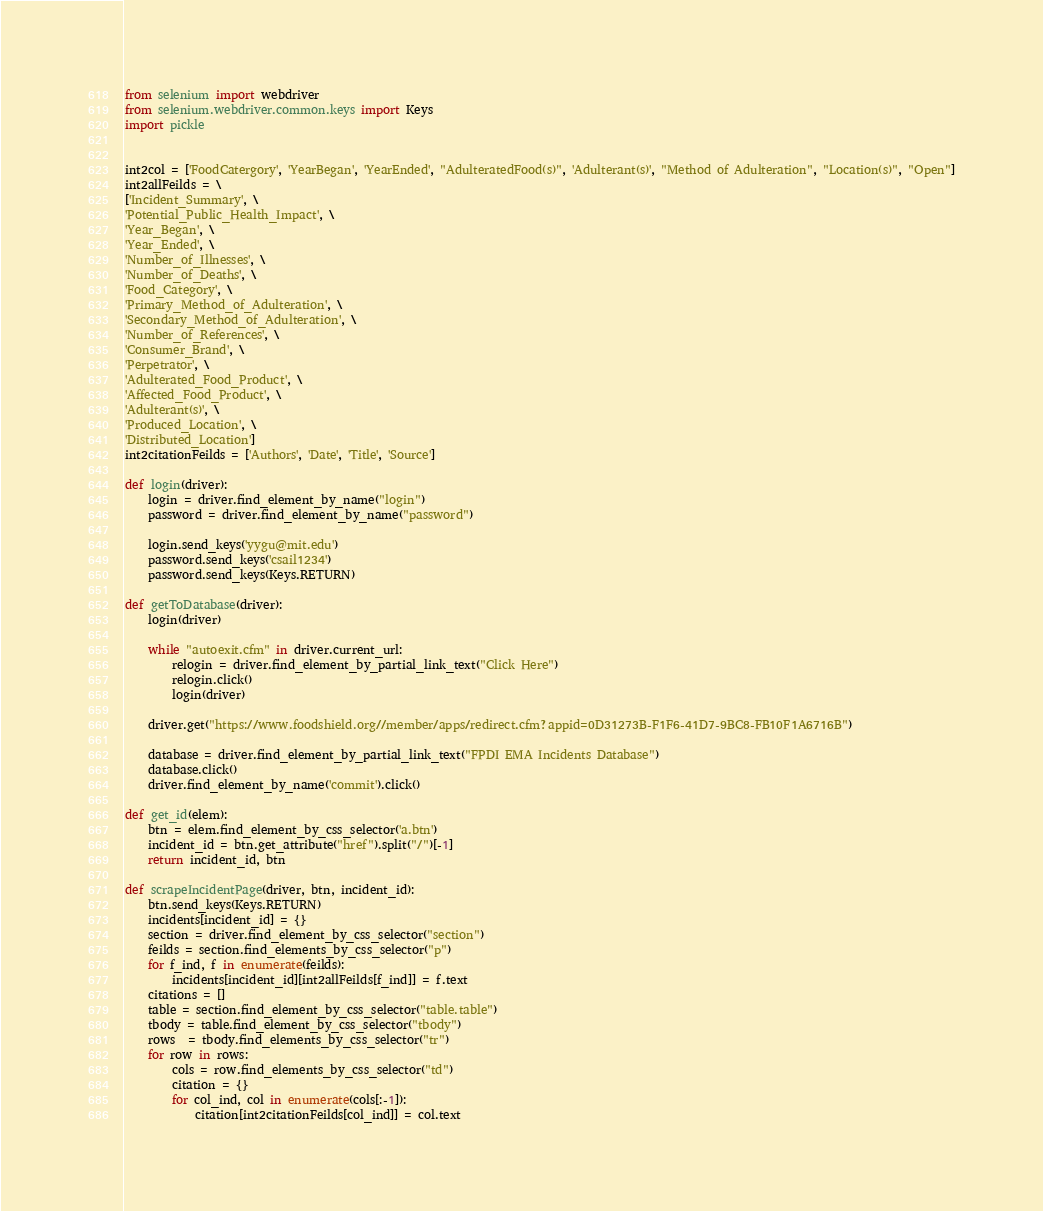Convert code to text. <code><loc_0><loc_0><loc_500><loc_500><_Python_>from selenium import webdriver
from selenium.webdriver.common.keys import Keys
import pickle


int2col = ['FoodCatergory', 'YearBegan', 'YearEnded', "AdulteratedFood(s)", 'Adulterant(s)', "Method of Adulteration", "Location(s)", "Open"]
int2allFeilds = \
['Incident_Summary', \
'Potential_Public_Health_Impact', \
'Year_Began', \
'Year_Ended', \
'Number_of_Illnesses', \
'Number_of_Deaths', \
'Food_Category', \
'Primary_Method_of_Adulteration', \
'Secondary_Method_of_Adulteration', \
'Number_of_References', \
'Consumer_Brand', \
'Perpetrator', \
'Adulterated_Food_Product', \
'Affected_Food_Product', \
'Adulterant(s)', \
'Produced_Location', \
'Distributed_Location']
int2citationFeilds = ['Authors', 'Date', 'Title', 'Source']

def login(driver):
	login = driver.find_element_by_name("login")
	password = driver.find_element_by_name("password")

	login.send_keys('yygu@mit.edu')
	password.send_keys('csail1234')
	password.send_keys(Keys.RETURN)

def getToDatabase(driver):
	login(driver)

	while "autoexit.cfm" in driver.current_url:
		relogin = driver.find_element_by_partial_link_text("Click Here")
		relogin.click()
		login(driver)

	driver.get("https://www.foodshield.org//member/apps/redirect.cfm?appid=0D31273B-F1F6-41D7-9BC8-FB10F1A6716B")

	database = driver.find_element_by_partial_link_text("FPDI EMA Incidents Database")
	database.click()
	driver.find_element_by_name('commit').click()

def get_id(elem):
	btn = elem.find_element_by_css_selector('a.btn')
	incident_id = btn.get_attribute("href").split("/")[-1]
	return incident_id, btn

def scrapeIncidentPage(driver, btn, incident_id):
	btn.send_keys(Keys.RETURN)
	incidents[incident_id] = {}
	section = driver.find_element_by_css_selector("section")
	feilds = section.find_elements_by_css_selector("p")
	for f_ind, f in enumerate(feilds):
		incidents[incident_id][int2allFeilds[f_ind]] = f.text
	citations = []
	table = section.find_element_by_css_selector("table.table")
	tbody = table.find_element_by_css_selector("tbody")
	rows  = tbody.find_elements_by_css_selector("tr")
	for row in rows:
		cols = row.find_elements_by_css_selector("td")
		citation = {}
		for col_ind, col in enumerate(cols[:-1]):
			citation[int2citationFeilds[col_ind]] = col.text</code> 